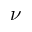Convert formula to latex. <formula><loc_0><loc_0><loc_500><loc_500>\nu</formula> 